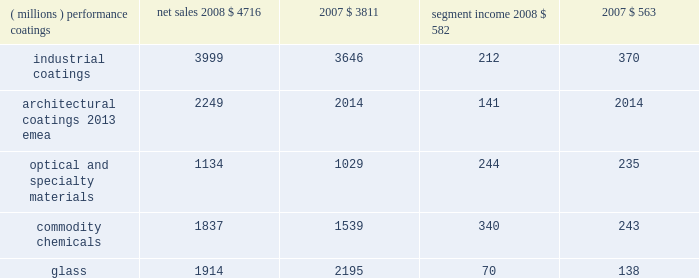Management 2019s discussion and analysis results of reportable business segments net sales segment income ( millions ) 2008 2007 2008 2007 .
Performance coatings sales increased $ 905 million or 24% ( 24 % ) in 2008 .
Sales increased 21% ( 21 % ) due to acquisitions , largely due to the impact of the sigmakalon protective and marine coatings business .
Sales also grew by 3% ( 3 % ) due to higher selling prices and 2% ( 2 % ) due to the positive impact of foreign currency translation .
Sales volumes declined 2% ( 2 % ) as reduced volumes in architectural coatings 2013 americas and asia pacific and automotive refinish were not fully offset by improved volumes in the aerospace and protective and marine businesses .
Volume growth in the aerospace businesses occurred throughout the world , while the volume growth in protective and marine coatings occurred primarily in asia .
Segment income increased $ 19 million in 2008 .
Factors increasing segment income were the positive impact of acquisitions , lower overhead costs and the positive impact of foreign currency translation .
The benefit of higher selling prices more than offset the negative impact of inflation , including higher raw materials and benefit costs .
Segment income was reduced by the impact of the lower sales volumes in architectural coatings and automotive refinish , which more than offset the benefit of volume gains in the aerospace and protective and marine coatings businesses .
Industrial coatings sales increased $ 353 million or 10% ( 10 % ) in 2008 .
Sales increased 11% ( 11 % ) due to acquisitions , including the impact of the sigmakalon industrial coatings business .
Sales also grew 3% ( 3 % ) due to the positive impact of foreign currency translation , and 1% ( 1 % ) from higher selling prices .
Sales volumes declined 5% ( 5 % ) as reduced volumes were experienced in all three businesses , reflecting the substantial declines in global demand .
Volume declines in the automotive and industrial businesses were primarily in the u.s .
And canada .
Additional volume declines in the european and asian regions were experienced by the industrial coatings business .
In packaging coatings , volume declines in europe were only partially offset by gains in asia and north america .
Segment income declined $ 158 million in 2008 due to the lower volumes and inflation , including higher raw material and freight costs , the impact of which was only partially mitigated by the increased selling prices .
Segment income also declined due to higher selling and distribution costs , including higher bad debt expense .
Factors increasing segment income were the earnings of acquired businesses , the positive impact of foreign currency translation and lower manufacturing costs .
Architectural coatings - emea sales for the year were $ 2249 million .
This business was acquired in the sigmakalon acquisition .
Segment income was $ 141 million , which included amortization expense of $ 63 million related to acquired intangible assets and depreciation expense of $ 58 million .
Optical and specialty materials sales increased $ 105 million or 10% ( 10 % ) in 2008 .
Sales increased 5% ( 5 % ) due to higher volumes in our optical products business resulting from the launch of transitions optical 2019s next generation lens product , 3% ( 3 % ) due to the positive impact of foreign currency translation and 2% ( 2 % ) due to increased selling prices .
Segment income increased $ 9 million in 2008 .
The increase in segment income was the result of increased sales volumes and the favorable impact of currency partially offset by increased selling and marketing costs in the optical products business related to the transitions optical product launch mentioned above .
Increased selling prices only partially offset higher raw material costs , primarily in our silicas business .
Commodity chemicals sales increased $ 298 million or 19% ( 19 % ) in 2008 .
Sales increased 18% ( 18 % ) due to higher selling prices and 1% ( 1 % ) due to improved sales volumes .
Segment income increased $ 97 million in 2008 .
Segment income increased in large part due to higher selling prices , which more than offset the negative impact of inflation , primarily higher raw material and energy costs .
Segment income also improved due to lower manufacturing costs , while lower margin mix and equity earnings reduced segment income .
Glass sales decreased $ 281 million or 13% ( 13 % ) in 2008 .
Sales decreased 11% ( 11 % ) due to the divestiture of the automotive glass and services business in september 2008 and 4% ( 4 % ) due to lower sales volumes .
Sales increased 2% ( 2 % ) due to higher selling prices .
Segment income decreased $ 68 million in 2008 .
Segment income decreased due to the divestiture of the automotive glass and services business , lower volumes , the negative impact of inflation and lower equity earnings from our asian fiber glass joint ventures .
Factors increasing segment income were lower manufacturing costs , higher selling prices and stronger foreign currency .
Outlook overall global economic activity was volatile in 2008 with an overall downward trend .
The north american economy continued a slowing trend which began during the second half of 2006 and continued all of 2007 .
The impact of the weakening u.s .
Economy was particularly 2008 ppg annual report and form 10-k 17 .
What was the net income margin in 2008 for the optical and specialty materials segment? 
Computations: (244 / 1134)
Answer: 0.21517. 